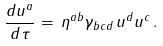Convert formula to latex. <formula><loc_0><loc_0><loc_500><loc_500>\frac { d u ^ { a } } { d \tau } = \, \eta ^ { a b } \gamma _ { b c d } \, u ^ { d } u ^ { c } \, .</formula> 